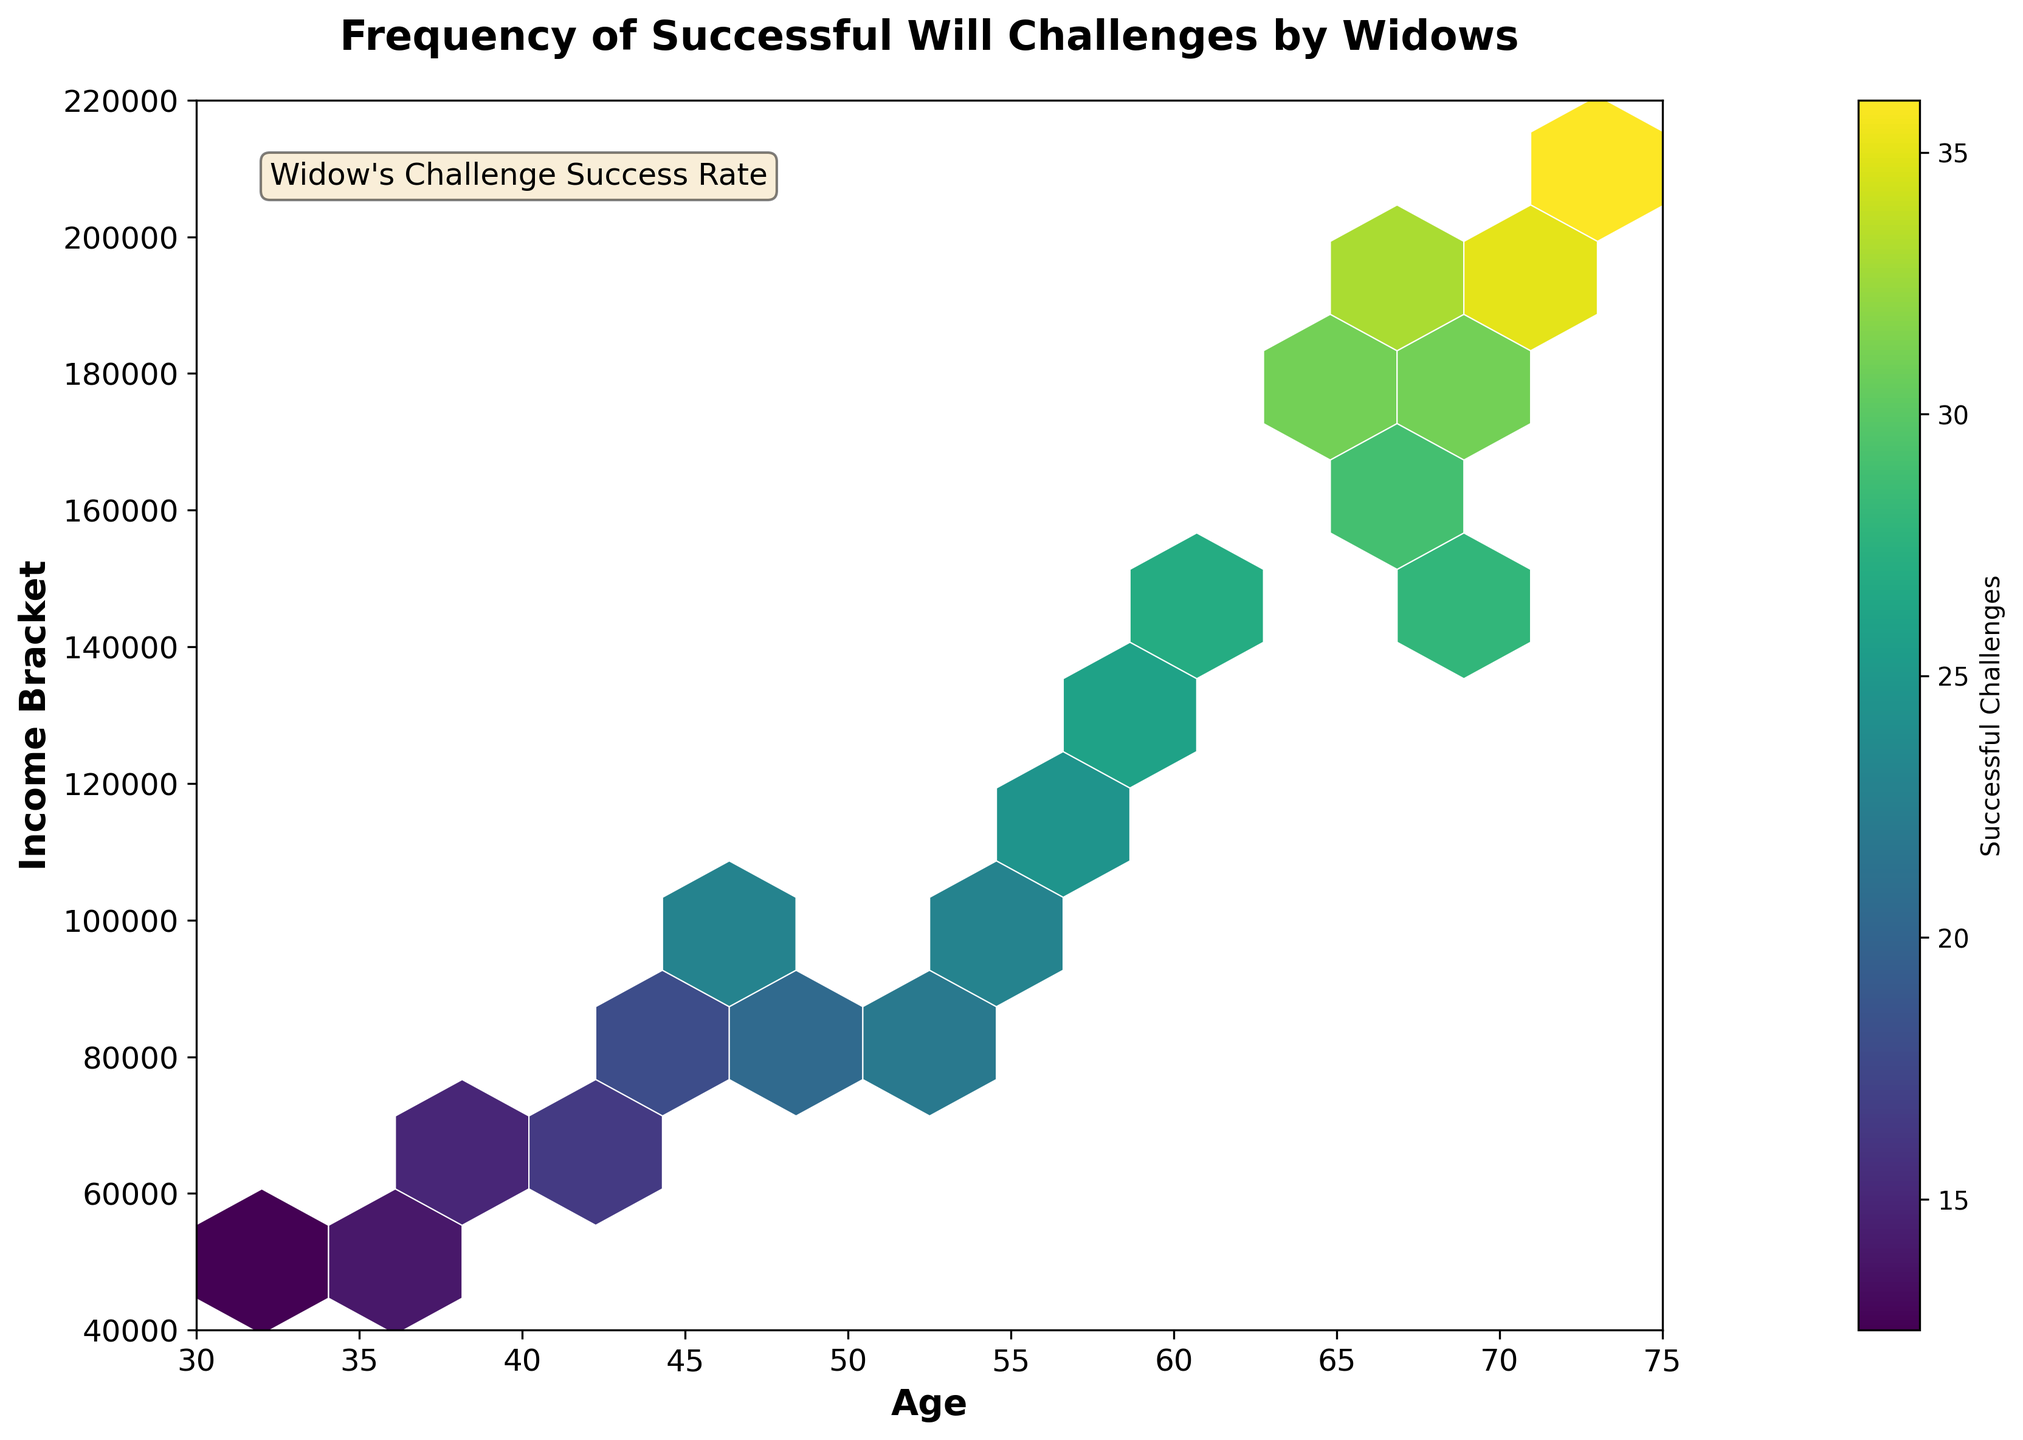How many successful challenges are represented in the highest income bracket (around $200,000)? The hexbin plot contains color gradients that represent the number of successful challenges. The bin closest to $200,000 has a dark shade. According to the color bar, darker shades correspond to higher values, indicating approximately 35 successful challenges.
Answer: 35 Which age group shows the highest frequency of successful challenges? The hexbin plot shows the frequency of successful challenges with color intensity. The highest intensity is around the 70-75 age bracket. The exact number can be seen as 71 (near $200,000).
Answer: 71 Are younger widows (under 40) generally less successful in challenging wills compared to older widows (60+)? By observing the color intensity of bins under age 40 and those over 60, the color is less dense in the younger age range and more dense in older age groups. Thus, older widows seem more successful.
Answer: Yes Comparing widows in the 45-50 age group and the 60-65 age group, which has a higher frequency of successful will challenges? Comparing the intensity of the hexbin colors between these age groups, the 60-65 age group has darker shades, indicating a higher frequency of successful challenges compared to the 45-50 age group.
Answer: 60-65 age group What can be inferred about the relationship between income and successful challenges? By looking at the increasing color intensity from lower to higher income brackets, it indicates a positive correlation: higher income widows tend to have more successful challenges.
Answer: Positive correlation In which income bracket do widows below age 40 most frequently succeed in will challenges? By observing the x-axis (age) under 40 and cross-referencing with hexbin color intensity, the most frequent successful challenges occur around the $50,000-$60,000 income bracket.
Answer: $50,000-$60,000 Is there a trend in successful will challenges regarding widow’s age as they approach 70? Consistently darker shades or more successful challenges are seen in the hexbin plot as age approaches 70, indicating an upward trend.
Answer: Upward trend How does the color bar explain the frequency of successful challenges in the hexbin plot? The color bar shows a gradient from light to dark, where light represents fewer and dark signifies more successful challenges, guiding the interpretation of data density.
Answer: Light to dark gradient Which combination of age and income shows the least successful challenges? The lightest bins in the hexbin plot, situated around ages 30-35 and income $40,000-$50,000, show the least successful challenges.
Answer: 30-35 age, $40,000-$50,000 income 